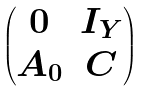<formula> <loc_0><loc_0><loc_500><loc_500>\begin{pmatrix} 0 & I _ { Y } \\ { A } _ { 0 } & C \end{pmatrix}</formula> 